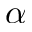Convert formula to latex. <formula><loc_0><loc_0><loc_500><loc_500>\alpha</formula> 